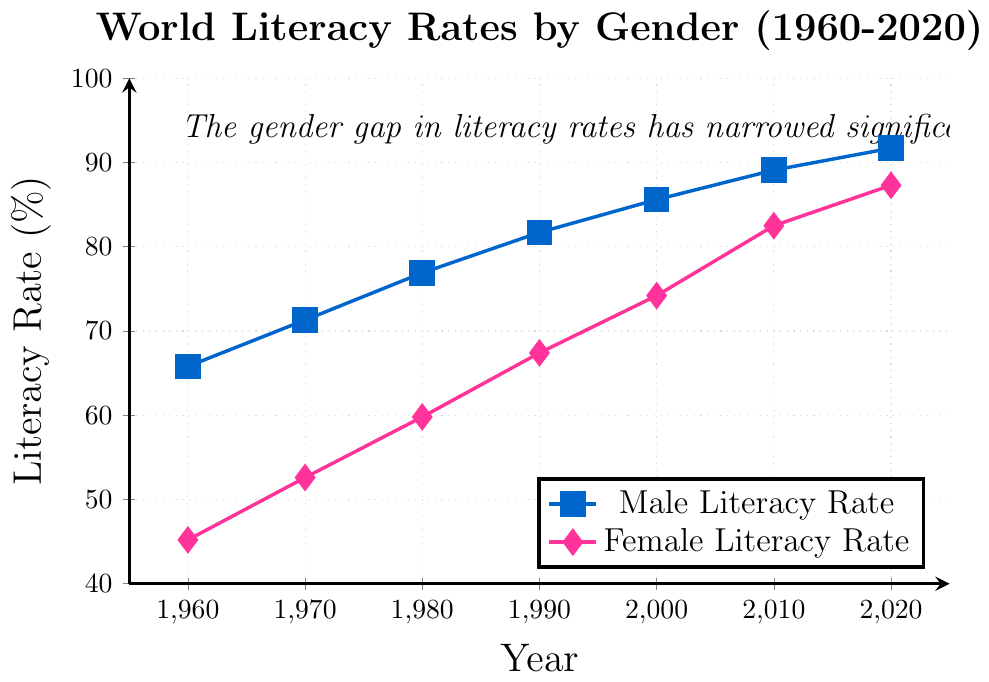What are the literacy rates for males and females in the year 1980? To find the literacy rates for males and females in 1980, look at the points marked with the year 1980 on the x-axis. Identify the corresponding values on the y-axis for both the male (square marker) and female (diamond marker) lines. For males, the rate is 76.9%, and for females, it is 59.8%
Answer: Male: 76.9%, Female: 59.8% In which year did the female literacy rate surpass 80%? Check the female literacy rate line (diamond marker) and find the point where it first goes above the 80% mark on the y-axis. This occurs between 2000 and 2010. The year is 2010
Answer: 2010 How much did the literacy rate for females increase from 1960 to 2020? To calculate the increase, subtract the literacy rate in 1960 from the rate in 2020 for females. The rate in 1960 is 45.2%, and in 2020, it is 87.3%. So, 87.3% - 45.2% = 42.1%
Answer: 42.1% Which gender had a higher literacy rate in 1990, and by how much? Compare the literacy rates for males and females in 1990 by looking at their respective lines. The male rate is 81.7%, and the female rate is 67.4%. Subtract the female rate from the male rate to find the difference: 81.7% - 67.4% = 14.3%
Answer: Male by 14.3% What is the average male literacy rate from 1960 to 2020? To find the average, sum all the male literacy rates from 1960, 1970, 1980, 1990, 2000, 2010, and 2020 and divide by the number of data points (7). The rates are 65.8%, 71.3%, 76.9%, 81.7%, 85.6%, 89.1%, and 91.7%. The sum is 562.1%, so the average is 562.1% / 7 = 80.3%
Answer: 80.3% What is the overall trend in the literacy gap between genders from 1960 to 2020? To determine the trend, observe the differences between the male and female literacy rates at each time point. The gap is decreasing over time as the female literacy rate increases at a faster pace compared to the male literacy rate. This indicates a narrowing of the education gap
Answer: Narrowing trend By how many percentage points did the male literacy rate increase from 2000 to 2020? First, find the male literacy rates for 2000 and 2020. The rates are 85.6% and 91.7%, respectively. Subtract the rate in 2000 from the rate in 2020: 91.7% - 85.6% = 6.1%
Answer: 6.1% 